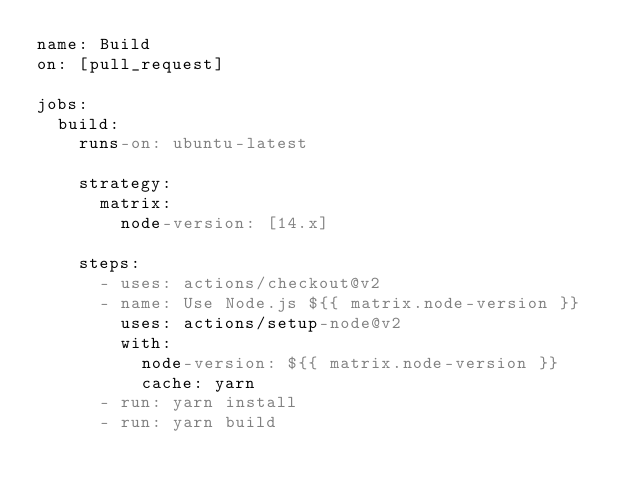Convert code to text. <code><loc_0><loc_0><loc_500><loc_500><_YAML_>name: Build
on: [pull_request]

jobs:
  build:
    runs-on: ubuntu-latest

    strategy:
      matrix:
        node-version: [14.x]

    steps:
      - uses: actions/checkout@v2
      - name: Use Node.js ${{ matrix.node-version }}
        uses: actions/setup-node@v2
        with:
          node-version: ${{ matrix.node-version }}
          cache: yarn
      - run: yarn install
      - run: yarn build
</code> 